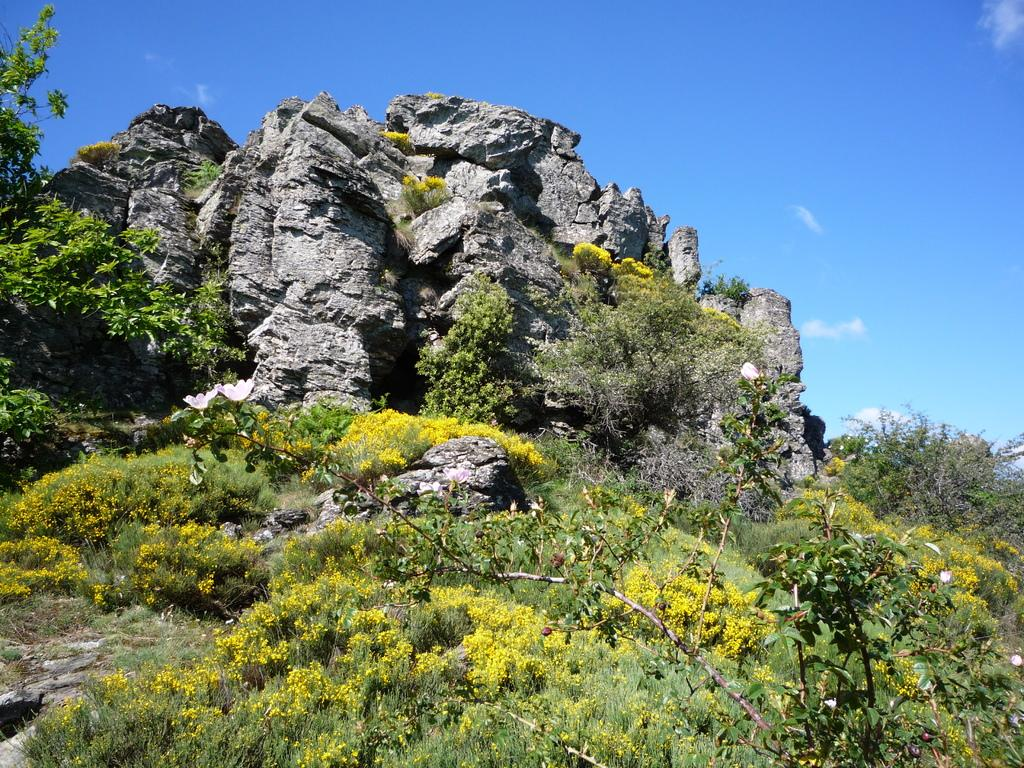What type of vegetation can be seen in the image? There are plants and trees in the image. What other objects are present in the image besides vegetation? There are rocks in the image. What can be seen in the background of the image? The sky is visible in the background of the image. What type of cloth is draped over the tree in the image? There is no cloth draped over the tree in the image; only plants, trees, rocks, and the sky are present. 